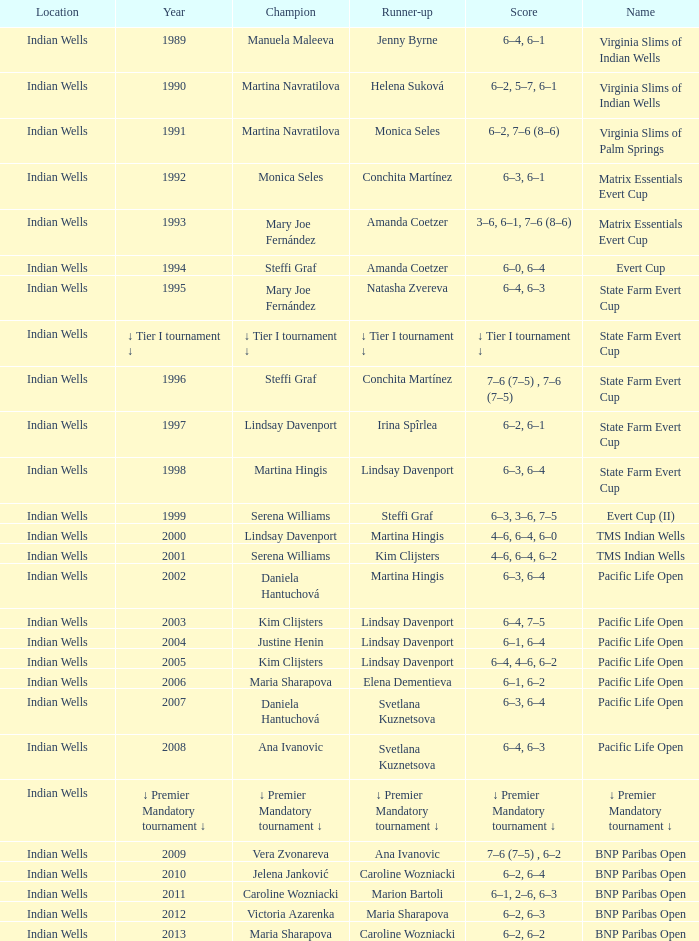Who was runner-up in the 2006 Pacific Life Open? Elena Dementieva. 